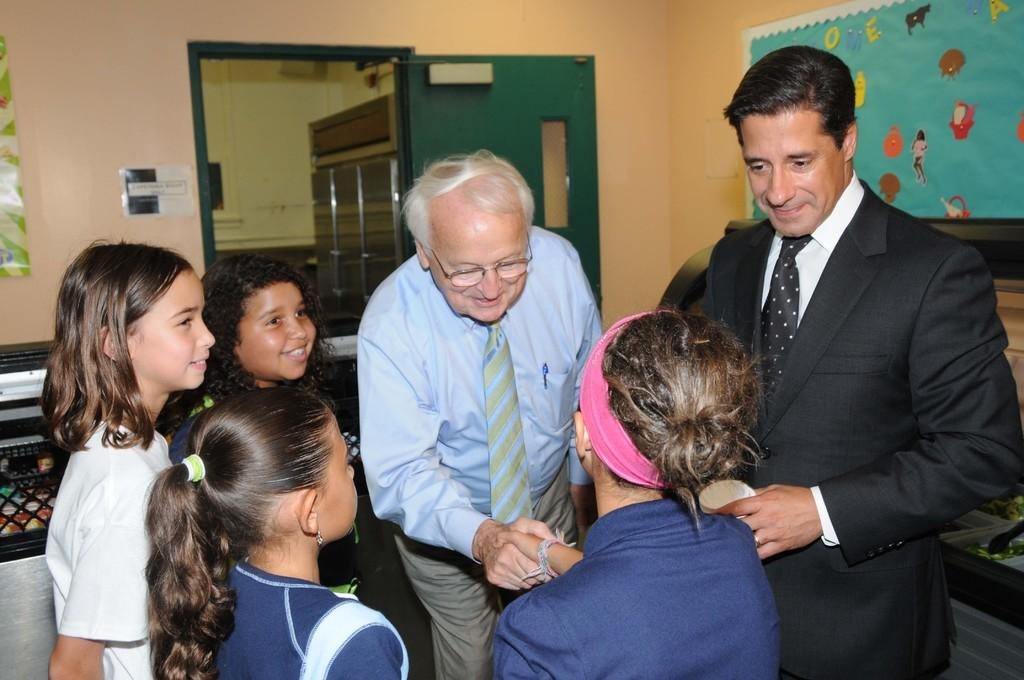What can be seen in the image? There is a group of people in the image. Can you describe the man in the middle of the image? The man in the middle of the image is wearing spectacles. What is visible in the background of the image? There is a door visible in the background of the image. What type of quilt is being used to cover the man in the image? There is no quilt present in the image; the man is not covered by any fabric. Can you see any smoke coming from the door in the background? There is no smoke visible in the image, and the door is not shown to be emitting any smoke. 